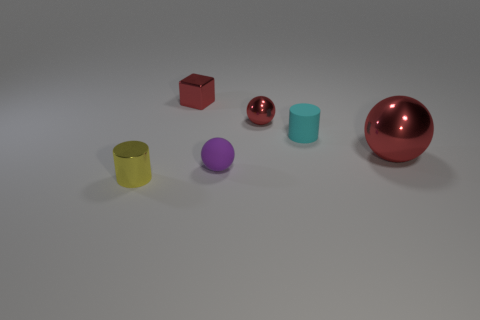Add 1 small cyan matte cylinders. How many objects exist? 7 Subtract all cylinders. How many objects are left? 4 Subtract 0 brown cylinders. How many objects are left? 6 Subtract all brown spheres. Subtract all small cyan rubber cylinders. How many objects are left? 5 Add 2 matte cylinders. How many matte cylinders are left? 3 Add 2 purple metallic blocks. How many purple metallic blocks exist? 2 